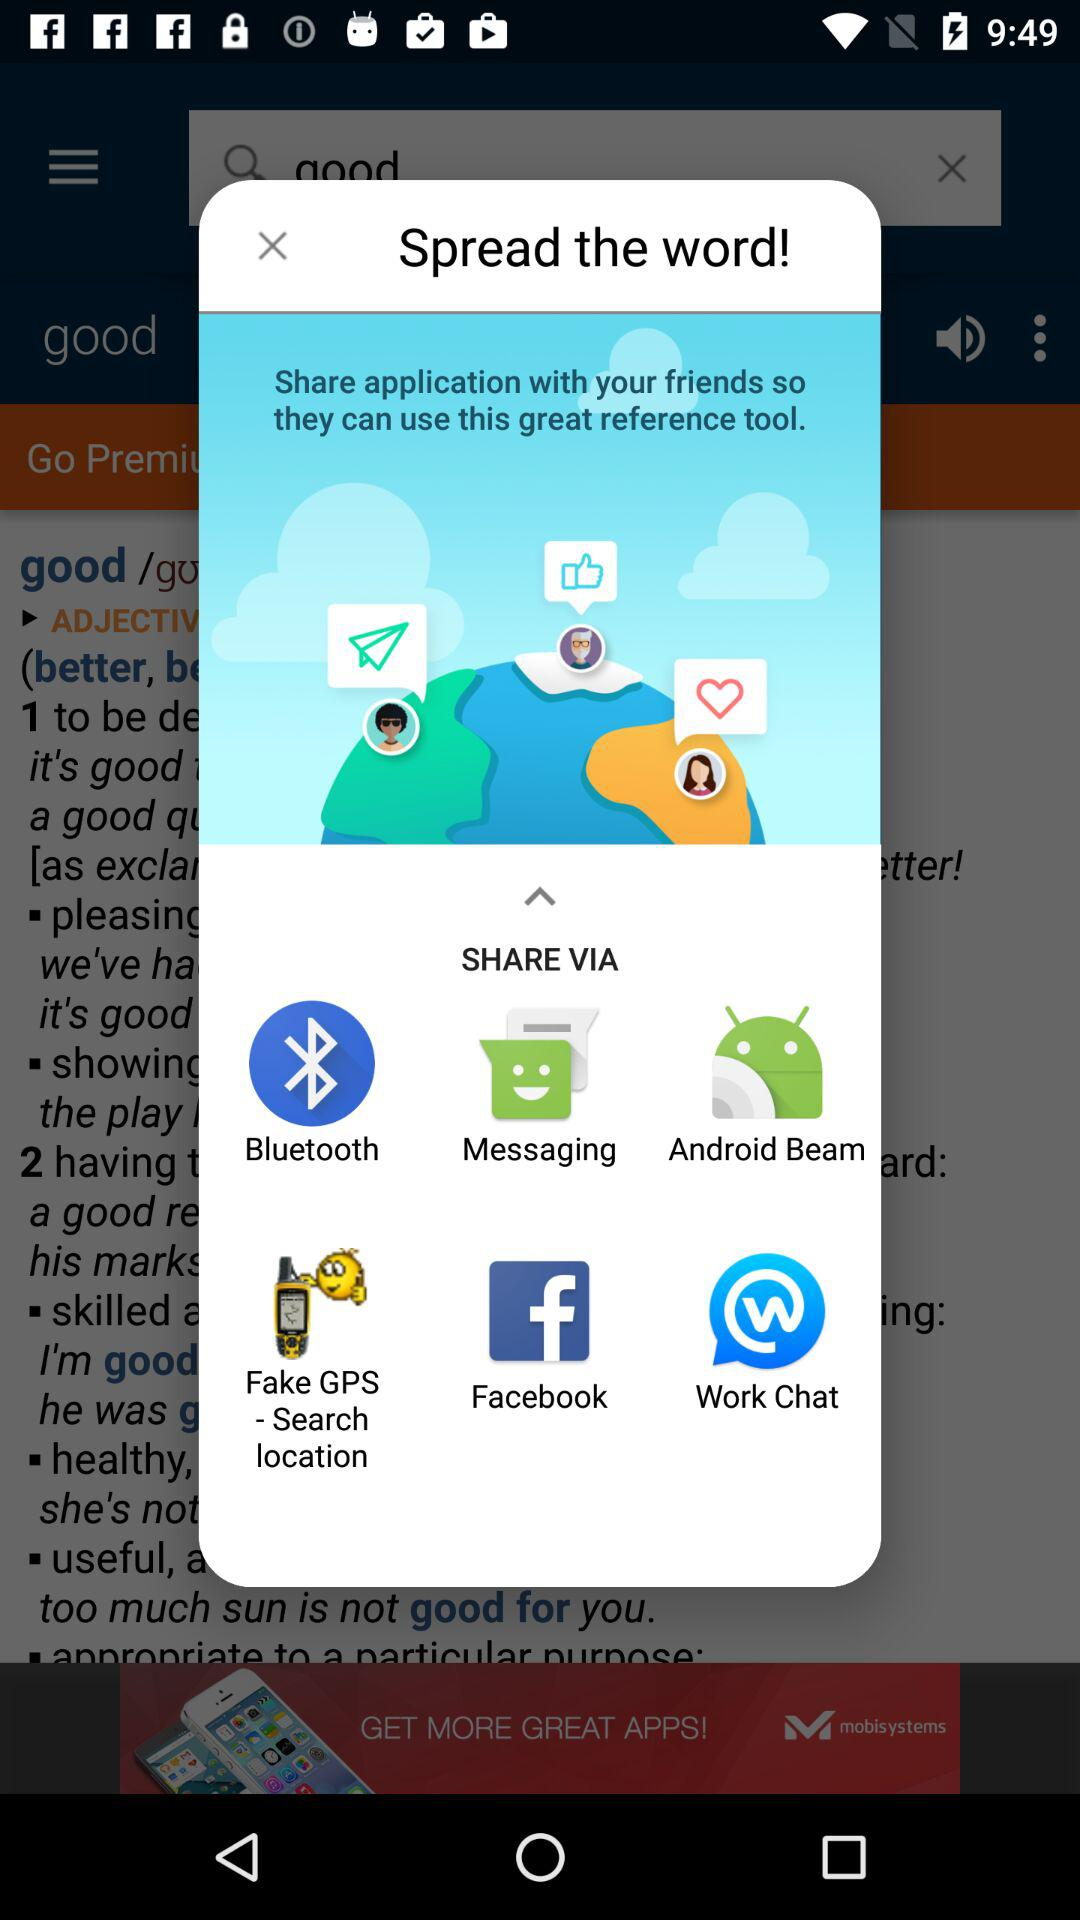What is the name of the user?
When the provided information is insufficient, respond with <no answer>. <no answer> 